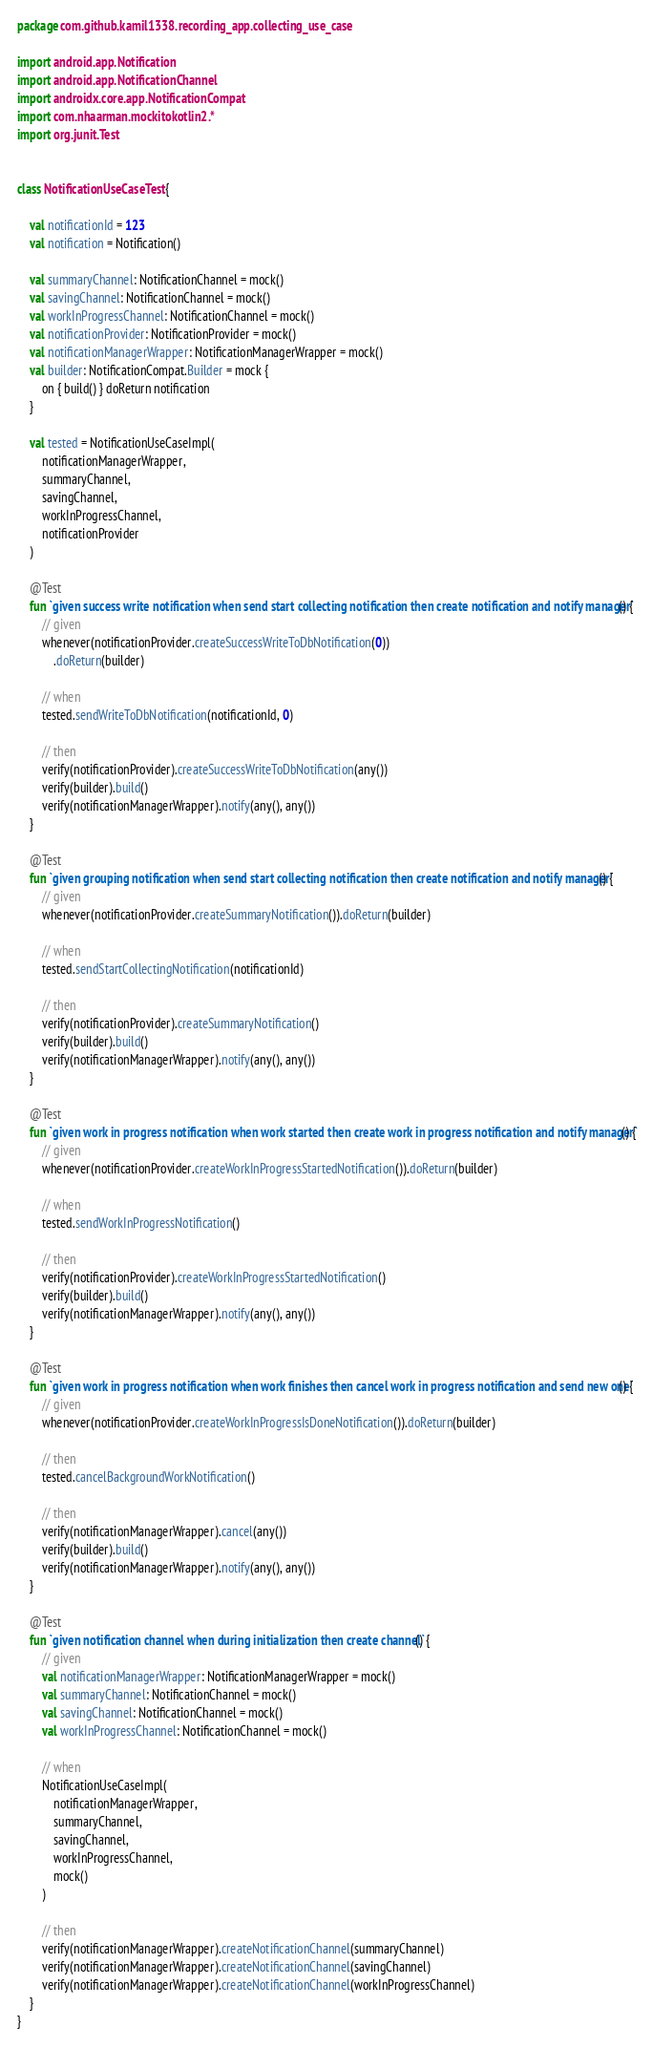<code> <loc_0><loc_0><loc_500><loc_500><_Kotlin_>package com.github.kamil1338.recording_app.collecting_use_case

import android.app.Notification
import android.app.NotificationChannel
import androidx.core.app.NotificationCompat
import com.nhaarman.mockitokotlin2.*
import org.junit.Test


class NotificationUseCaseTest {

    val notificationId = 123
    val notification = Notification()

    val summaryChannel: NotificationChannel = mock()
    val savingChannel: NotificationChannel = mock()
    val workInProgressChannel: NotificationChannel = mock()
    val notificationProvider: NotificationProvider = mock()
    val notificationManagerWrapper: NotificationManagerWrapper = mock()
    val builder: NotificationCompat.Builder = mock {
        on { build() } doReturn notification
    }

    val tested = NotificationUseCaseImpl(
        notificationManagerWrapper,
        summaryChannel,
        savingChannel,
        workInProgressChannel,
        notificationProvider
    )

    @Test
    fun `given success write notification when send start collecting notification then create notification and notify manager`() {
        // given
        whenever(notificationProvider.createSuccessWriteToDbNotification(0))
            .doReturn(builder)

        // when
        tested.sendWriteToDbNotification(notificationId, 0)

        // then
        verify(notificationProvider).createSuccessWriteToDbNotification(any())
        verify(builder).build()
        verify(notificationManagerWrapper).notify(any(), any())
    }

    @Test
    fun `given grouping notification when send start collecting notification then create notification and notify manager`() {
        // given
        whenever(notificationProvider.createSummaryNotification()).doReturn(builder)

        // when
        tested.sendStartCollectingNotification(notificationId)

        // then
        verify(notificationProvider).createSummaryNotification()
        verify(builder).build()
        verify(notificationManagerWrapper).notify(any(), any())
    }

    @Test
    fun `given work in progress notification when work started then create work in progress notification and notify manager`() {
        // given
        whenever(notificationProvider.createWorkInProgressStartedNotification()).doReturn(builder)

        // when
        tested.sendWorkInProgressNotification()

        // then
        verify(notificationProvider).createWorkInProgressStartedNotification()
        verify(builder).build()
        verify(notificationManagerWrapper).notify(any(), any())
    }

    @Test
    fun `given work in progress notification when work finishes then cancel work in progress notification and send new one`() {
        // given
        whenever(notificationProvider.createWorkInProgressIsDoneNotification()).doReturn(builder)

        // then
        tested.cancelBackgroundWorkNotification()

        // then
        verify(notificationManagerWrapper).cancel(any())
        verify(builder).build()
        verify(notificationManagerWrapper).notify(any(), any())
    }

    @Test
    fun `given notification channel when during initialization then create channel`() {
        // given
        val notificationManagerWrapper: NotificationManagerWrapper = mock()
        val summaryChannel: NotificationChannel = mock()
        val savingChannel: NotificationChannel = mock()
        val workInProgressChannel: NotificationChannel = mock()

        // when
        NotificationUseCaseImpl(
            notificationManagerWrapper,
            summaryChannel,
            savingChannel,
            workInProgressChannel,
            mock()
        )

        // then
        verify(notificationManagerWrapper).createNotificationChannel(summaryChannel)
        verify(notificationManagerWrapper).createNotificationChannel(savingChannel)
        verify(notificationManagerWrapper).createNotificationChannel(workInProgressChannel)
    }
}</code> 